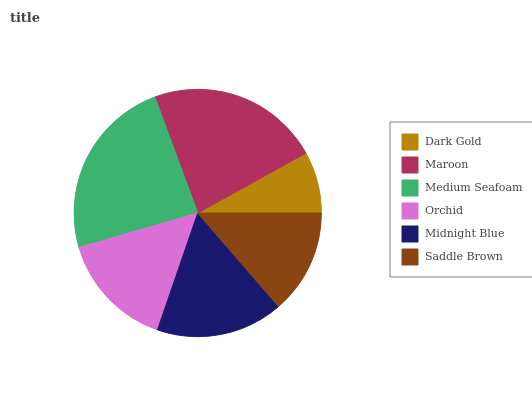Is Dark Gold the minimum?
Answer yes or no. Yes. Is Medium Seafoam the maximum?
Answer yes or no. Yes. Is Maroon the minimum?
Answer yes or no. No. Is Maroon the maximum?
Answer yes or no. No. Is Maroon greater than Dark Gold?
Answer yes or no. Yes. Is Dark Gold less than Maroon?
Answer yes or no. Yes. Is Dark Gold greater than Maroon?
Answer yes or no. No. Is Maroon less than Dark Gold?
Answer yes or no. No. Is Midnight Blue the high median?
Answer yes or no. Yes. Is Orchid the low median?
Answer yes or no. Yes. Is Medium Seafoam the high median?
Answer yes or no. No. Is Medium Seafoam the low median?
Answer yes or no. No. 